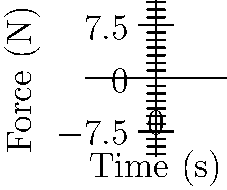The graph shows the force distribution over time for two different prosthetic foot designs during a gait cycle. Which design would likely provide better stability during the stance phase, and why? To determine which prosthetic foot design provides better stability during the stance phase, we need to analyze the force distribution graphs:

1. Identify the stance phase: The stance phase typically occurs in the first half of the gait cycle, so we'll focus on the left side of the graph (approximately 0-2 seconds).

2. Analyze Design A (blue curve):
   - Starts with a moderate force
   - Force increases rapidly and reaches a high peak
   - Force decreases quickly after the peak

3. Analyze Design B (red curve):
   - Starts with a slightly higher force
   - Force increases more gradually
   - Reaches a lower peak compared to Design A
   - Force decreases more slowly after the peak

4. Compare stability features:
   - A more gradual increase and decrease in force generally provides better stability
   - A lower peak force can reduce the risk of instability
   - A higher initial force can provide better ground contact at heel strike

5. Conclusion:
   Design B (red curve) would likely provide better stability during the stance phase because:
   - It has a more gradual increase and decrease in force
   - It has a lower peak force
   - It starts with a slightly higher initial force

These characteristics suggest that Design B would offer a more controlled and stable force distribution throughout the stance phase of the gait cycle.
Answer: Design B, due to its gradual force changes and lower peak force. 